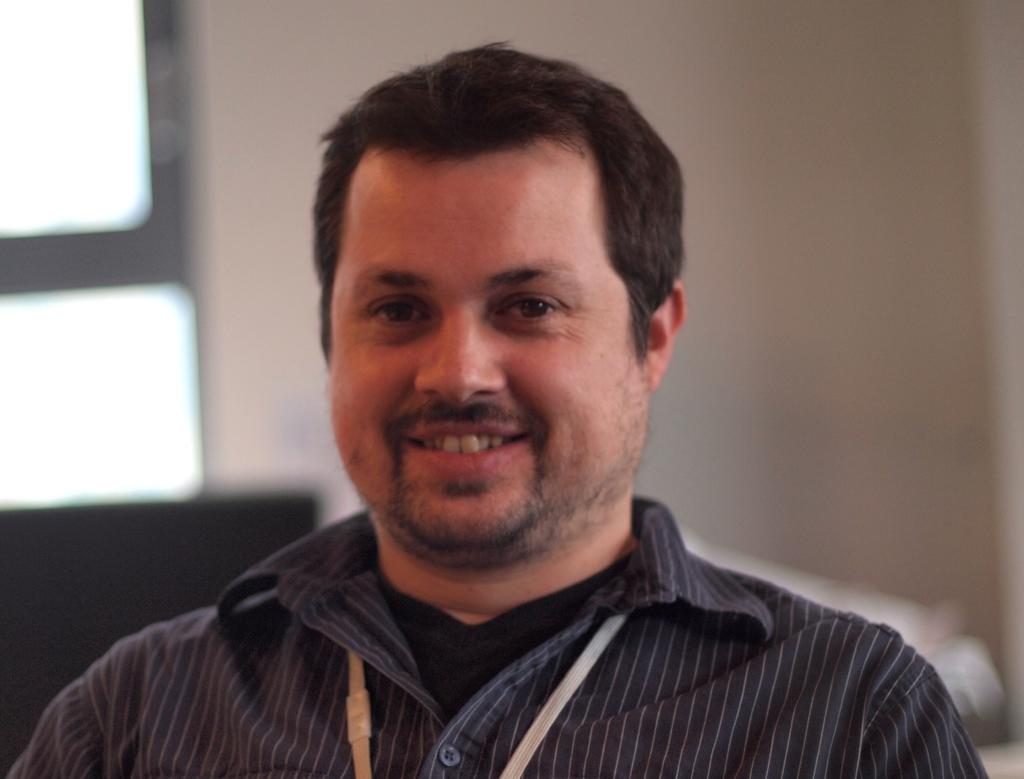What is the main subject of the picture? The main subject of the picture is a man. What expression does the man have in the image? The man is smiling in the image. Can you describe the background of the picture? The background of the image is blurred. How many bags of pizzas can be seen in the image? There are no bags or pizzas present in the image. What type of lizards can be seen crawling on the man's shoulder in the image? There are no lizards present in the image. 